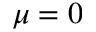<formula> <loc_0><loc_0><loc_500><loc_500>\mu = 0</formula> 